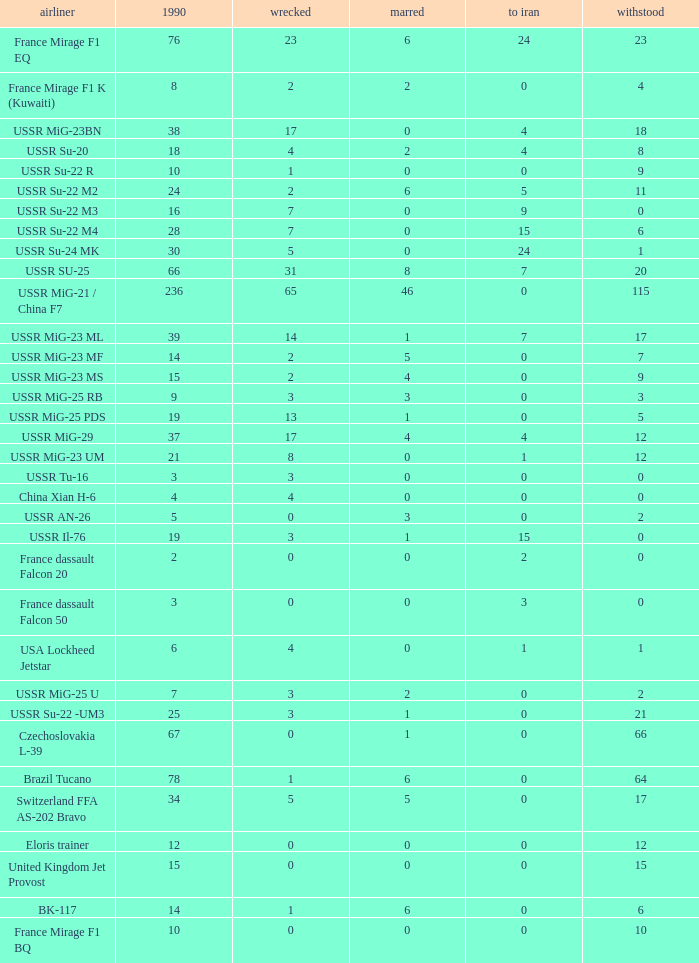If 4 went to iran and the amount that survived was less than 12.0 how many were there in 1990? 1.0. 